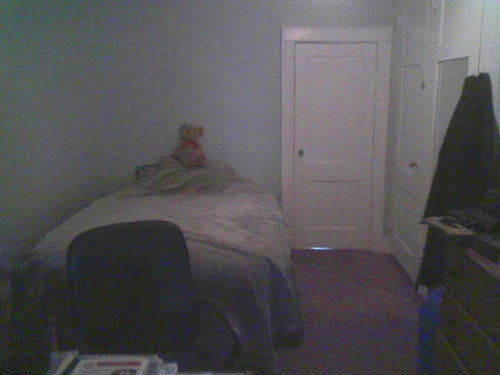Describe the objects in this image and their specific colors. I can see bed in teal, gray, black, and darkgreen tones, chair in teal, black, navy, gray, and darkgreen tones, book in teal, gray, purple, and black tones, and teddy bear in teal, gray, black, and purple tones in this image. 